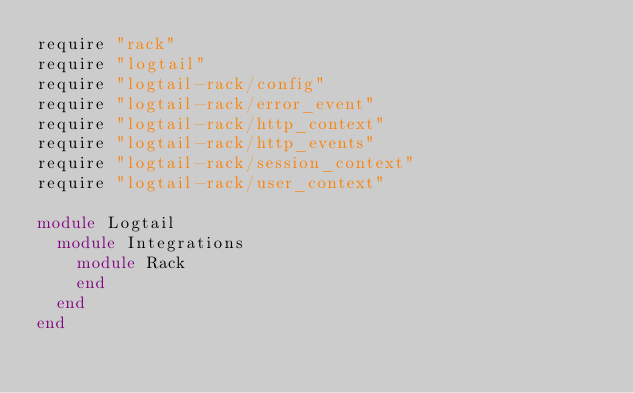<code> <loc_0><loc_0><loc_500><loc_500><_Ruby_>require "rack"
require "logtail"
require "logtail-rack/config"
require "logtail-rack/error_event"
require "logtail-rack/http_context"
require "logtail-rack/http_events"
require "logtail-rack/session_context"
require "logtail-rack/user_context"

module Logtail
  module Integrations
    module Rack
    end
  end
end

</code> 